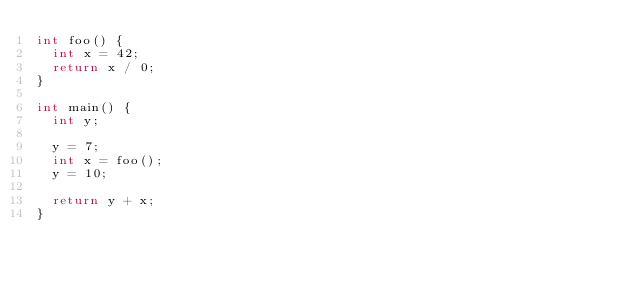<code> <loc_0><loc_0><loc_500><loc_500><_C++_>int foo() {
  int x = 42;
  return x / 0;
}

int main() {
  int y;

  y = 7;
  int x = foo();
  y = 10;

  return y + x;
}
</code> 